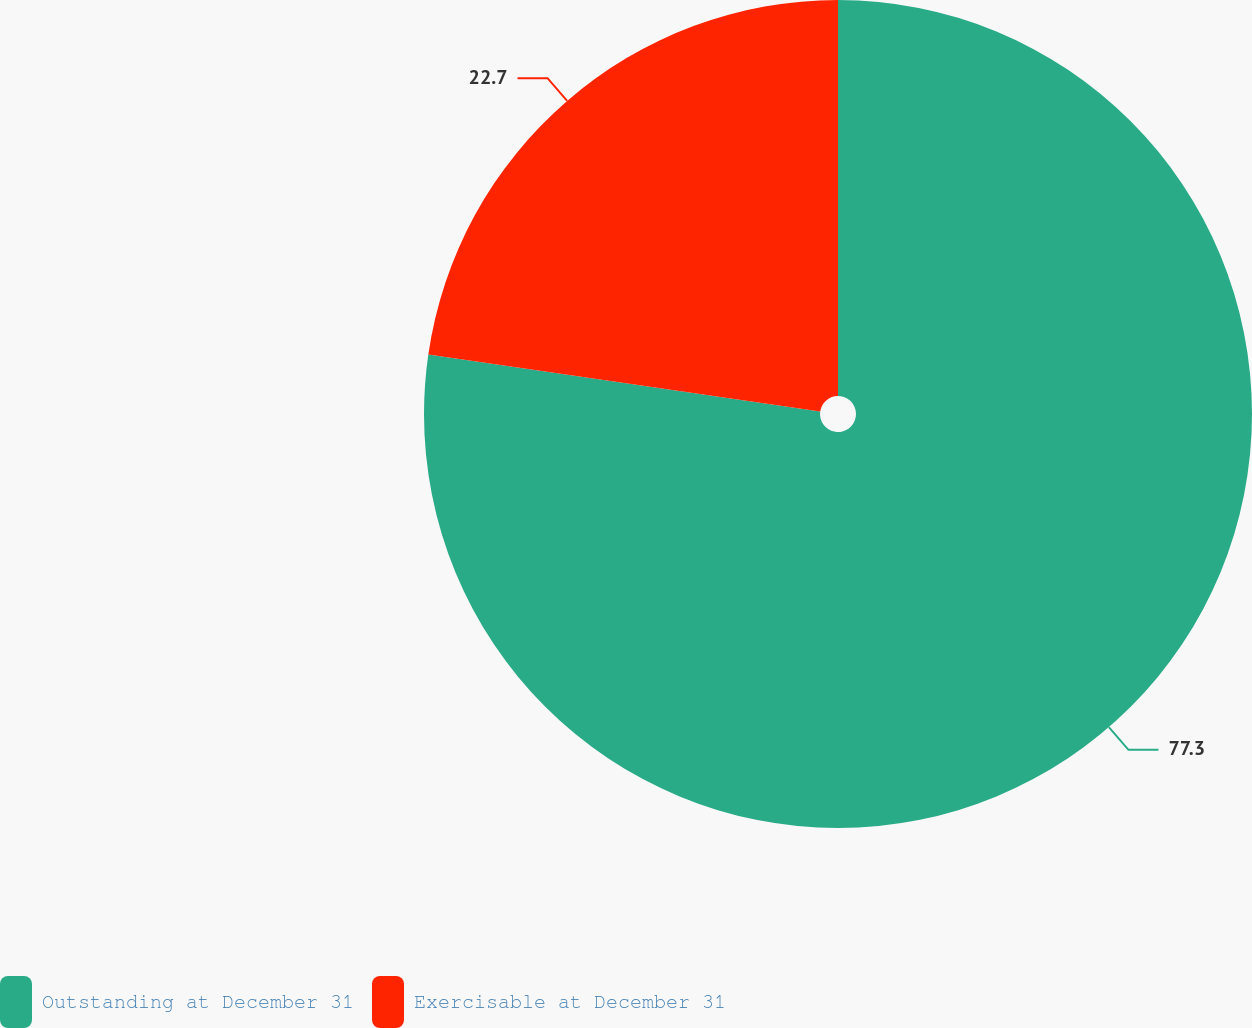<chart> <loc_0><loc_0><loc_500><loc_500><pie_chart><fcel>Outstanding at December 31<fcel>Exercisable at December 31<nl><fcel>77.3%<fcel>22.7%<nl></chart> 